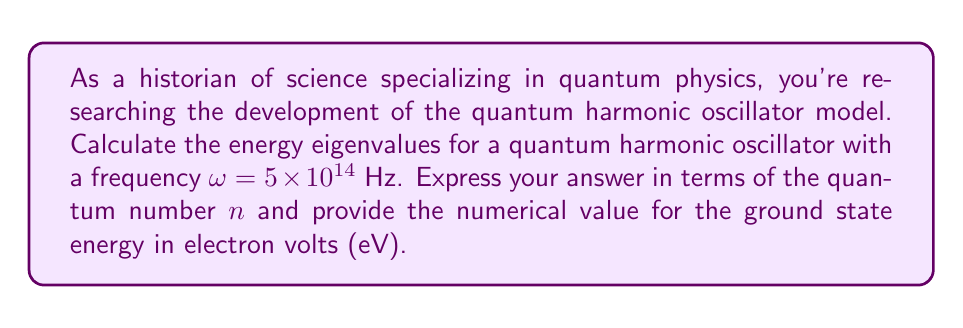Show me your answer to this math problem. To solve this problem, we'll follow these steps:

1) The energy eigenvalues for a quantum harmonic oscillator are given by the equation:

   $$E_n = \hbar \omega (n + \frac{1}{2})$$

   where $n$ is the quantum number (n = 0, 1, 2, ...), $\hbar$ is the reduced Planck's constant, and $\omega$ is the angular frequency of the oscillator.

2) We're given $\omega = 5 \times 10^{14}$ Hz. We need to use this in our equation.

3) First, let's express the energy eigenvalues in terms of $n$:

   $$E_n = \hbar (5 \times 10^{14}) (n + \frac{1}{2})$$

4) To calculate the numerical value for the ground state (n = 0), we need to use the value of $\hbar$:

   $\hbar = 1.0545718 \times 10^{-34}$ J⋅s

5) Substituting this into our equation for n = 0:

   $$E_0 = (1.0545718 \times 10^{-34})(5 \times 10^{14})(\frac{1}{2})$$

6) Calculating:

   $$E_0 = 2.636429 \times 10^{-20}$$ J

7) To convert this to eV, we divide by the charge of an electron (e = 1.602176634 × 10^-19 C):

   $$E_0 = \frac{2.636429 \times 10^{-20}}{1.602176634 \times 10^{-19}} = 0.1645$$ eV

Thus, we have our general formula for energy eigenvalues and the numerical value for the ground state energy.
Answer: Energy eigenvalues: $E_n = \hbar \omega (n + \frac{1}{2}) = (5.272859 \times 10^{-20})(n + \frac{1}{2})$ J
Ground state energy: $E_0 = 0.1645$ eV 